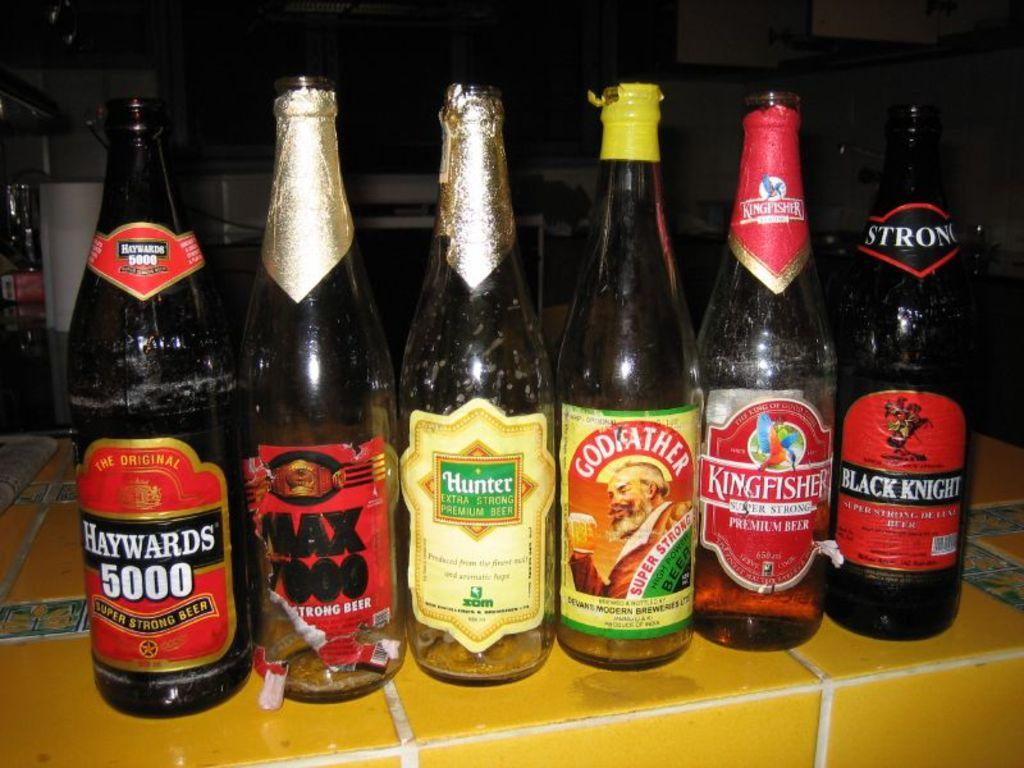What can be seen in the image that is related to beverages? There are bottles with different tags in the image. Where are the bottles placed in the image? The bottles are placed on a tiled floor. What is the color of the background in the image? The background in the image is dark. What can be seen in the background besides the dark color? There are rolls visible in the background. What type of grip can be seen on the sail in the image? There is no sail or grip present in the image; it features bottles with different tags on a tiled floor with a dark background and rolls visible in the background. 